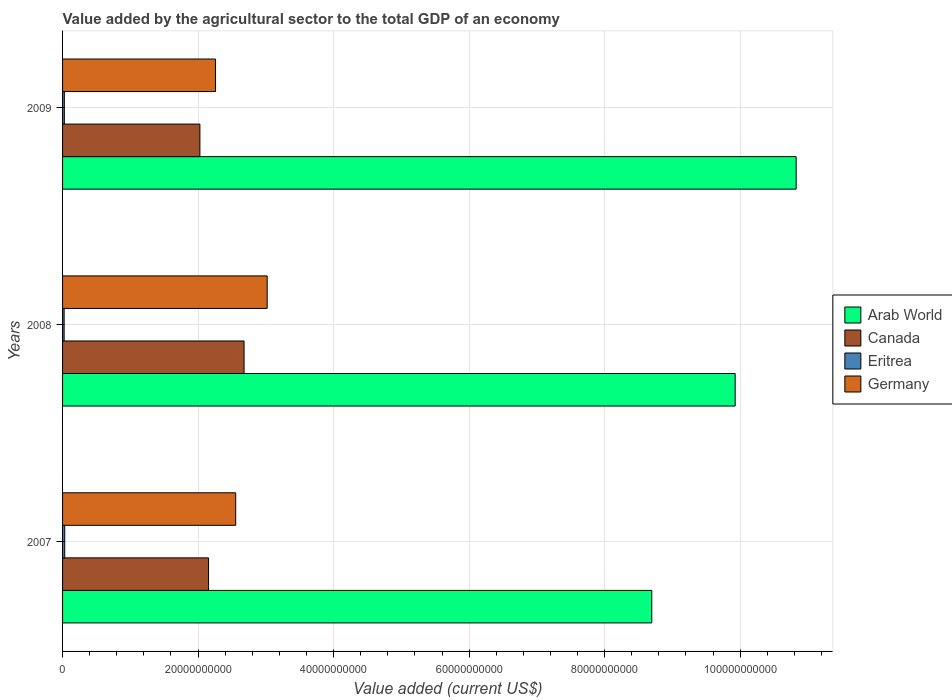Are the number of bars on each tick of the Y-axis equal?
Make the answer very short. Yes. How many bars are there on the 1st tick from the bottom?
Offer a very short reply. 4. What is the label of the 2nd group of bars from the top?
Your response must be concise. 2008. What is the value added by the agricultural sector to the total GDP in Eritrea in 2008?
Your response must be concise. 2.32e+08. Across all years, what is the maximum value added by the agricultural sector to the total GDP in Canada?
Provide a succinct answer. 2.68e+1. Across all years, what is the minimum value added by the agricultural sector to the total GDP in Arab World?
Offer a very short reply. 8.70e+1. In which year was the value added by the agricultural sector to the total GDP in Canada maximum?
Your answer should be very brief. 2008. What is the total value added by the agricultural sector to the total GDP in Arab World in the graph?
Keep it short and to the point. 2.94e+11. What is the difference between the value added by the agricultural sector to the total GDP in Arab World in 2007 and that in 2009?
Keep it short and to the point. -2.13e+1. What is the difference between the value added by the agricultural sector to the total GDP in Arab World in 2008 and the value added by the agricultural sector to the total GDP in Eritrea in 2007?
Give a very brief answer. 9.89e+1. What is the average value added by the agricultural sector to the total GDP in Canada per year?
Offer a terse response. 2.29e+1. In the year 2007, what is the difference between the value added by the agricultural sector to the total GDP in Canada and value added by the agricultural sector to the total GDP in Eritrea?
Keep it short and to the point. 2.12e+1. In how many years, is the value added by the agricultural sector to the total GDP in Germany greater than 28000000000 US$?
Your answer should be very brief. 1. What is the ratio of the value added by the agricultural sector to the total GDP in Eritrea in 2008 to that in 2009?
Make the answer very short. 0.88. Is the difference between the value added by the agricultural sector to the total GDP in Canada in 2008 and 2009 greater than the difference between the value added by the agricultural sector to the total GDP in Eritrea in 2008 and 2009?
Offer a terse response. Yes. What is the difference between the highest and the second highest value added by the agricultural sector to the total GDP in Eritrea?
Provide a short and direct response. 5.76e+07. What is the difference between the highest and the lowest value added by the agricultural sector to the total GDP in Eritrea?
Make the answer very short. 8.83e+07. In how many years, is the value added by the agricultural sector to the total GDP in Arab World greater than the average value added by the agricultural sector to the total GDP in Arab World taken over all years?
Ensure brevity in your answer.  2. What does the 4th bar from the top in 2007 represents?
Keep it short and to the point. Arab World. What does the 1st bar from the bottom in 2008 represents?
Give a very brief answer. Arab World. Is it the case that in every year, the sum of the value added by the agricultural sector to the total GDP in Canada and value added by the agricultural sector to the total GDP in Eritrea is greater than the value added by the agricultural sector to the total GDP in Germany?
Offer a terse response. No. How many bars are there?
Your response must be concise. 12. Are all the bars in the graph horizontal?
Your answer should be very brief. Yes. Are the values on the major ticks of X-axis written in scientific E-notation?
Offer a terse response. No. Does the graph contain any zero values?
Keep it short and to the point. No. Where does the legend appear in the graph?
Offer a terse response. Center right. How are the legend labels stacked?
Keep it short and to the point. Vertical. What is the title of the graph?
Provide a short and direct response. Value added by the agricultural sector to the total GDP of an economy. Does "East Asia (developing only)" appear as one of the legend labels in the graph?
Offer a terse response. No. What is the label or title of the X-axis?
Provide a short and direct response. Value added (current US$). What is the label or title of the Y-axis?
Your answer should be compact. Years. What is the Value added (current US$) in Arab World in 2007?
Your answer should be very brief. 8.70e+1. What is the Value added (current US$) of Canada in 2007?
Provide a short and direct response. 2.15e+1. What is the Value added (current US$) in Eritrea in 2007?
Your response must be concise. 3.20e+08. What is the Value added (current US$) in Germany in 2007?
Make the answer very short. 2.56e+1. What is the Value added (current US$) of Arab World in 2008?
Your answer should be very brief. 9.93e+1. What is the Value added (current US$) in Canada in 2008?
Offer a very short reply. 2.68e+1. What is the Value added (current US$) of Eritrea in 2008?
Make the answer very short. 2.32e+08. What is the Value added (current US$) in Germany in 2008?
Provide a short and direct response. 3.02e+1. What is the Value added (current US$) of Arab World in 2009?
Your response must be concise. 1.08e+11. What is the Value added (current US$) of Canada in 2009?
Your answer should be very brief. 2.03e+1. What is the Value added (current US$) in Eritrea in 2009?
Ensure brevity in your answer.  2.62e+08. What is the Value added (current US$) in Germany in 2009?
Offer a very short reply. 2.26e+1. Across all years, what is the maximum Value added (current US$) of Arab World?
Offer a very short reply. 1.08e+11. Across all years, what is the maximum Value added (current US$) of Canada?
Your answer should be very brief. 2.68e+1. Across all years, what is the maximum Value added (current US$) in Eritrea?
Provide a short and direct response. 3.20e+08. Across all years, what is the maximum Value added (current US$) of Germany?
Offer a terse response. 3.02e+1. Across all years, what is the minimum Value added (current US$) in Arab World?
Keep it short and to the point. 8.70e+1. Across all years, what is the minimum Value added (current US$) in Canada?
Offer a very short reply. 2.03e+1. Across all years, what is the minimum Value added (current US$) in Eritrea?
Keep it short and to the point. 2.32e+08. Across all years, what is the minimum Value added (current US$) of Germany?
Offer a terse response. 2.26e+1. What is the total Value added (current US$) of Arab World in the graph?
Offer a very short reply. 2.94e+11. What is the total Value added (current US$) in Canada in the graph?
Provide a short and direct response. 6.86e+1. What is the total Value added (current US$) of Eritrea in the graph?
Ensure brevity in your answer.  8.14e+08. What is the total Value added (current US$) in Germany in the graph?
Provide a short and direct response. 7.83e+1. What is the difference between the Value added (current US$) of Arab World in 2007 and that in 2008?
Provide a succinct answer. -1.23e+1. What is the difference between the Value added (current US$) in Canada in 2007 and that in 2008?
Keep it short and to the point. -5.24e+09. What is the difference between the Value added (current US$) in Eritrea in 2007 and that in 2008?
Your answer should be compact. 8.83e+07. What is the difference between the Value added (current US$) in Germany in 2007 and that in 2008?
Give a very brief answer. -4.65e+09. What is the difference between the Value added (current US$) in Arab World in 2007 and that in 2009?
Ensure brevity in your answer.  -2.13e+1. What is the difference between the Value added (current US$) in Canada in 2007 and that in 2009?
Your answer should be very brief. 1.28e+09. What is the difference between the Value added (current US$) of Eritrea in 2007 and that in 2009?
Keep it short and to the point. 5.76e+07. What is the difference between the Value added (current US$) in Germany in 2007 and that in 2009?
Provide a succinct answer. 2.98e+09. What is the difference between the Value added (current US$) of Arab World in 2008 and that in 2009?
Offer a very short reply. -9.00e+09. What is the difference between the Value added (current US$) of Canada in 2008 and that in 2009?
Your response must be concise. 6.52e+09. What is the difference between the Value added (current US$) in Eritrea in 2008 and that in 2009?
Ensure brevity in your answer.  -3.07e+07. What is the difference between the Value added (current US$) in Germany in 2008 and that in 2009?
Your answer should be very brief. 7.62e+09. What is the difference between the Value added (current US$) in Arab World in 2007 and the Value added (current US$) in Canada in 2008?
Make the answer very short. 6.02e+1. What is the difference between the Value added (current US$) of Arab World in 2007 and the Value added (current US$) of Eritrea in 2008?
Offer a very short reply. 8.67e+1. What is the difference between the Value added (current US$) in Arab World in 2007 and the Value added (current US$) in Germany in 2008?
Provide a short and direct response. 5.68e+1. What is the difference between the Value added (current US$) of Canada in 2007 and the Value added (current US$) of Eritrea in 2008?
Your answer should be very brief. 2.13e+1. What is the difference between the Value added (current US$) of Canada in 2007 and the Value added (current US$) of Germany in 2008?
Offer a very short reply. -8.65e+09. What is the difference between the Value added (current US$) in Eritrea in 2007 and the Value added (current US$) in Germany in 2008?
Give a very brief answer. -2.99e+1. What is the difference between the Value added (current US$) in Arab World in 2007 and the Value added (current US$) in Canada in 2009?
Your answer should be very brief. 6.67e+1. What is the difference between the Value added (current US$) of Arab World in 2007 and the Value added (current US$) of Eritrea in 2009?
Keep it short and to the point. 8.67e+1. What is the difference between the Value added (current US$) of Arab World in 2007 and the Value added (current US$) of Germany in 2009?
Offer a terse response. 6.44e+1. What is the difference between the Value added (current US$) in Canada in 2007 and the Value added (current US$) in Eritrea in 2009?
Your response must be concise. 2.13e+1. What is the difference between the Value added (current US$) in Canada in 2007 and the Value added (current US$) in Germany in 2009?
Give a very brief answer. -1.03e+09. What is the difference between the Value added (current US$) of Eritrea in 2007 and the Value added (current US$) of Germany in 2009?
Make the answer very short. -2.23e+1. What is the difference between the Value added (current US$) of Arab World in 2008 and the Value added (current US$) of Canada in 2009?
Provide a short and direct response. 7.90e+1. What is the difference between the Value added (current US$) of Arab World in 2008 and the Value added (current US$) of Eritrea in 2009?
Provide a short and direct response. 9.90e+1. What is the difference between the Value added (current US$) in Arab World in 2008 and the Value added (current US$) in Germany in 2009?
Keep it short and to the point. 7.67e+1. What is the difference between the Value added (current US$) of Canada in 2008 and the Value added (current US$) of Eritrea in 2009?
Give a very brief answer. 2.65e+1. What is the difference between the Value added (current US$) in Canada in 2008 and the Value added (current US$) in Germany in 2009?
Your answer should be compact. 4.21e+09. What is the difference between the Value added (current US$) of Eritrea in 2008 and the Value added (current US$) of Germany in 2009?
Keep it short and to the point. -2.23e+1. What is the average Value added (current US$) in Arab World per year?
Make the answer very short. 9.82e+1. What is the average Value added (current US$) of Canada per year?
Provide a short and direct response. 2.29e+1. What is the average Value added (current US$) of Eritrea per year?
Ensure brevity in your answer.  2.71e+08. What is the average Value added (current US$) of Germany per year?
Offer a very short reply. 2.61e+1. In the year 2007, what is the difference between the Value added (current US$) in Arab World and Value added (current US$) in Canada?
Provide a succinct answer. 6.54e+1. In the year 2007, what is the difference between the Value added (current US$) of Arab World and Value added (current US$) of Eritrea?
Your answer should be compact. 8.66e+1. In the year 2007, what is the difference between the Value added (current US$) in Arab World and Value added (current US$) in Germany?
Your answer should be very brief. 6.14e+1. In the year 2007, what is the difference between the Value added (current US$) in Canada and Value added (current US$) in Eritrea?
Make the answer very short. 2.12e+1. In the year 2007, what is the difference between the Value added (current US$) of Canada and Value added (current US$) of Germany?
Your response must be concise. -4.01e+09. In the year 2007, what is the difference between the Value added (current US$) in Eritrea and Value added (current US$) in Germany?
Provide a short and direct response. -2.52e+1. In the year 2008, what is the difference between the Value added (current US$) of Arab World and Value added (current US$) of Canada?
Keep it short and to the point. 7.25e+1. In the year 2008, what is the difference between the Value added (current US$) of Arab World and Value added (current US$) of Eritrea?
Offer a terse response. 9.90e+1. In the year 2008, what is the difference between the Value added (current US$) of Arab World and Value added (current US$) of Germany?
Offer a terse response. 6.91e+1. In the year 2008, what is the difference between the Value added (current US$) of Canada and Value added (current US$) of Eritrea?
Offer a terse response. 2.66e+1. In the year 2008, what is the difference between the Value added (current US$) in Canada and Value added (current US$) in Germany?
Ensure brevity in your answer.  -3.41e+09. In the year 2008, what is the difference between the Value added (current US$) in Eritrea and Value added (current US$) in Germany?
Offer a terse response. -3.00e+1. In the year 2009, what is the difference between the Value added (current US$) in Arab World and Value added (current US$) in Canada?
Offer a terse response. 8.80e+1. In the year 2009, what is the difference between the Value added (current US$) of Arab World and Value added (current US$) of Eritrea?
Your answer should be compact. 1.08e+11. In the year 2009, what is the difference between the Value added (current US$) in Arab World and Value added (current US$) in Germany?
Keep it short and to the point. 8.57e+1. In the year 2009, what is the difference between the Value added (current US$) of Canada and Value added (current US$) of Eritrea?
Offer a very short reply. 2.00e+1. In the year 2009, what is the difference between the Value added (current US$) in Canada and Value added (current US$) in Germany?
Make the answer very short. -2.30e+09. In the year 2009, what is the difference between the Value added (current US$) of Eritrea and Value added (current US$) of Germany?
Keep it short and to the point. -2.23e+1. What is the ratio of the Value added (current US$) in Arab World in 2007 to that in 2008?
Provide a short and direct response. 0.88. What is the ratio of the Value added (current US$) in Canada in 2007 to that in 2008?
Your answer should be very brief. 0.8. What is the ratio of the Value added (current US$) in Eritrea in 2007 to that in 2008?
Your answer should be very brief. 1.38. What is the ratio of the Value added (current US$) of Germany in 2007 to that in 2008?
Offer a terse response. 0.85. What is the ratio of the Value added (current US$) in Arab World in 2007 to that in 2009?
Offer a terse response. 0.8. What is the ratio of the Value added (current US$) of Canada in 2007 to that in 2009?
Offer a very short reply. 1.06. What is the ratio of the Value added (current US$) in Eritrea in 2007 to that in 2009?
Give a very brief answer. 1.22. What is the ratio of the Value added (current US$) of Germany in 2007 to that in 2009?
Offer a terse response. 1.13. What is the ratio of the Value added (current US$) of Arab World in 2008 to that in 2009?
Offer a very short reply. 0.92. What is the ratio of the Value added (current US$) of Canada in 2008 to that in 2009?
Your answer should be compact. 1.32. What is the ratio of the Value added (current US$) of Eritrea in 2008 to that in 2009?
Give a very brief answer. 0.88. What is the ratio of the Value added (current US$) of Germany in 2008 to that in 2009?
Your answer should be very brief. 1.34. What is the difference between the highest and the second highest Value added (current US$) in Arab World?
Provide a succinct answer. 9.00e+09. What is the difference between the highest and the second highest Value added (current US$) of Canada?
Your answer should be very brief. 5.24e+09. What is the difference between the highest and the second highest Value added (current US$) of Eritrea?
Your answer should be very brief. 5.76e+07. What is the difference between the highest and the second highest Value added (current US$) of Germany?
Ensure brevity in your answer.  4.65e+09. What is the difference between the highest and the lowest Value added (current US$) in Arab World?
Your answer should be compact. 2.13e+1. What is the difference between the highest and the lowest Value added (current US$) in Canada?
Keep it short and to the point. 6.52e+09. What is the difference between the highest and the lowest Value added (current US$) in Eritrea?
Give a very brief answer. 8.83e+07. What is the difference between the highest and the lowest Value added (current US$) of Germany?
Offer a terse response. 7.62e+09. 